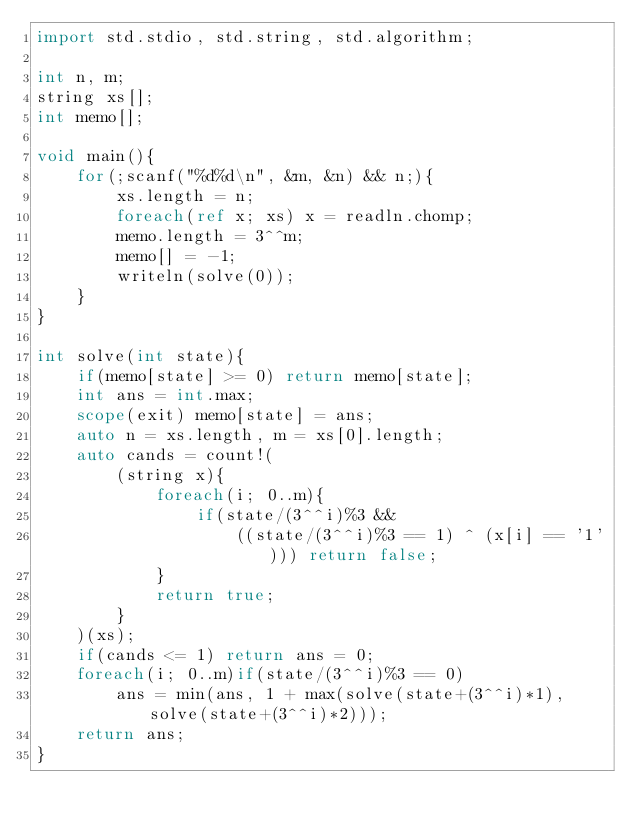Convert code to text. <code><loc_0><loc_0><loc_500><loc_500><_D_>import std.stdio, std.string, std.algorithm;

int n, m;
string xs[];
int memo[];

void main(){
	for(;scanf("%d%d\n", &m, &n) && n;){
		xs.length = n;
		foreach(ref x; xs) x = readln.chomp;
		memo.length = 3^^m;
		memo[] = -1;
		writeln(solve(0));
	}
}

int solve(int state){
	if(memo[state] >= 0) return memo[state];
	int ans = int.max;
	scope(exit) memo[state] = ans;
	auto n = xs.length, m = xs[0].length;
	auto cands = count!(
		(string x){
			foreach(i; 0..m){
				if(state/(3^^i)%3 &&
					((state/(3^^i)%3 == 1) ^ (x[i] == '1'))) return false;
			}
			return true;
		}
	)(xs);
	if(cands <= 1) return ans = 0;
	foreach(i; 0..m)if(state/(3^^i)%3 == 0)
		ans = min(ans, 1 + max(solve(state+(3^^i)*1), solve(state+(3^^i)*2)));
	return ans;
}</code> 